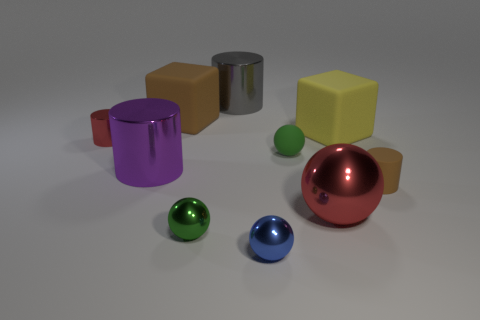Subtract all cubes. How many objects are left? 8 Subtract 1 purple cylinders. How many objects are left? 9 Subtract all big brown matte things. Subtract all matte cubes. How many objects are left? 7 Add 4 tiny blue things. How many tiny blue things are left? 5 Add 10 yellow metallic cylinders. How many yellow metallic cylinders exist? 10 